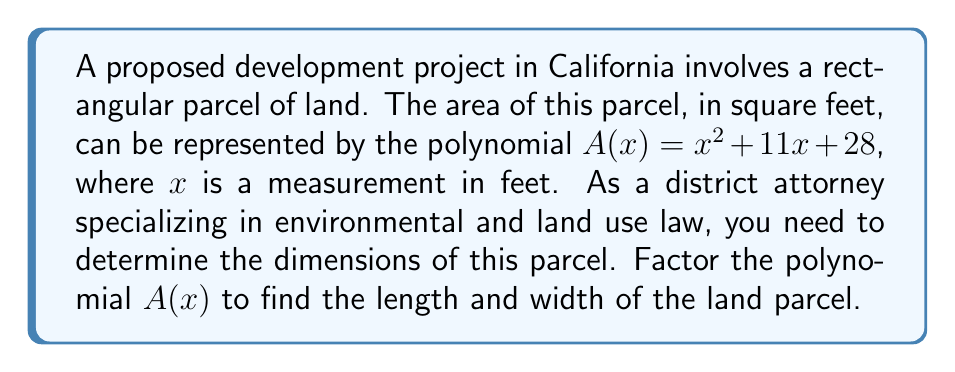Show me your answer to this math problem. To factor the polynomial $A(x) = x^2 + 11x + 28$, we'll use the following steps:

1) First, identify that this is a quadratic polynomial in the form $ax^2 + bx + c$, where $a=1$, $b=11$, and $c=28$.

2) We need to find two numbers that multiply to give $ac = 1 \times 28 = 28$ and add up to $b = 11$.

3) The factors of 28 are: 1, 2, 4, 7, 14, 28. By inspection, we can see that 4 and 7 add up to 11.

4) Rewrite the middle term using these numbers:
   $A(x) = x^2 + 4x + 7x + 28$

5) Group the terms:
   $A(x) = (x^2 + 4x) + (7x + 28)$

6) Factor out the common factors from each group:
   $A(x) = x(x + 4) + 7(x + 4)$

7) Factor out the common binomial $(x + 4)$:
   $A(x) = (x + 7)(x + 4)$

Therefore, the polynomial has been factored into $(x + 7)(x + 4)$.

In the context of the land parcel, this means:
- The length of the parcel is $x + 7$ feet
- The width of the parcel is $x + 4$ feet

where $x$ is some positive number of feet.
Answer: $(x + 7)(x + 4)$ 